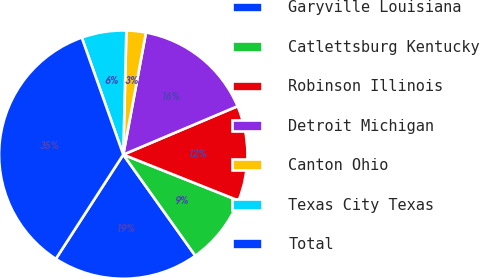Convert chart to OTSL. <chart><loc_0><loc_0><loc_500><loc_500><pie_chart><fcel>Garyville Louisiana<fcel>Catlettsburg Kentucky<fcel>Robinson Illinois<fcel>Detroit Michigan<fcel>Canton Ohio<fcel>Texas City Texas<fcel>Total<nl><fcel>18.99%<fcel>9.11%<fcel>12.41%<fcel>15.7%<fcel>2.53%<fcel>5.82%<fcel>35.44%<nl></chart> 